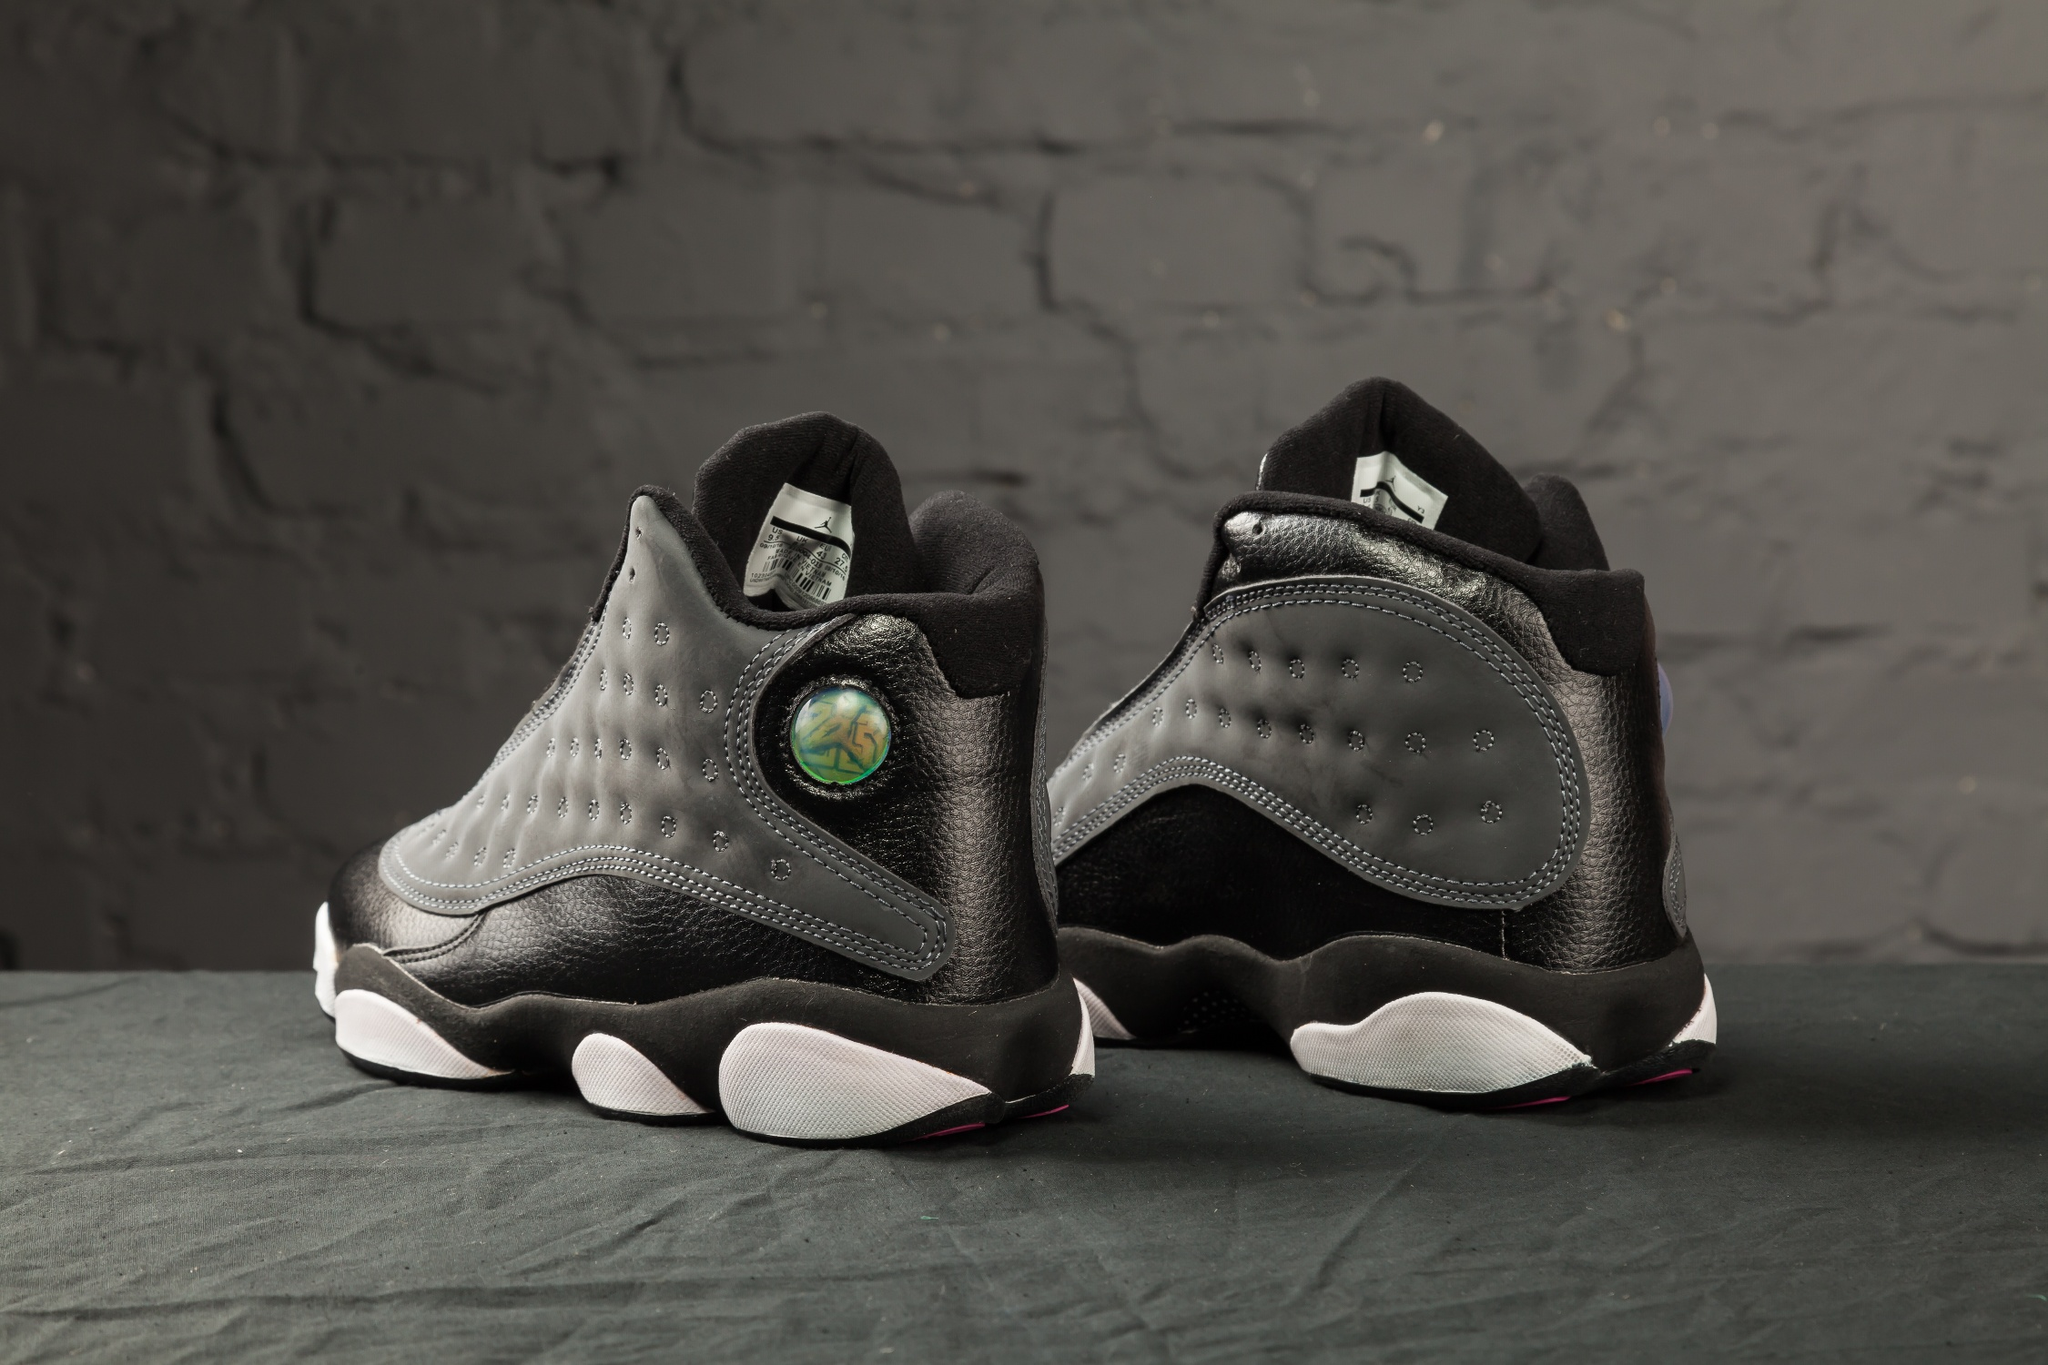What can you say about the details of the sneakers? The sneakers are intricately designed, featuring a combination of smooth black leather and textured gray patches. The black upper is studded with subtle perforations that add to the sleek aesthetic. The standout feature is a holographic circular emblem near the heel, which captures the light and adds a unique flair. The interior appears to be well-padded, suggesting comfort. The white soles bear a slightly textured grip, indicating practicality in addition to style. Overall, the sneakers are a blend of modern fashion and usability. Can you provide some imaginative context for these sneakers? These sneakers could easily belong to an urban explorer in a futuristic cityscape. Picture a world where style and adaptability are key, and our explorer navigates neon-lit streets and towering skyscrapers. The holographic logo on the sneakers might be a tech-enhanced feature, unlocking special functions or serving as an ID for accessing exclusive locations. The sturdy yet fashionable build ensures that the wearer is prepared for anything, blending seamlessly into both high-society events and gritty underground meetups. Describe a realistic scenario where someone might wear these sneakers. These sneakers could be worn by a young professional in a bustling city. They might pair them with slim-fit jeans and a stylish jacket, perfect for a day that transitions from office meetings to evening social gatherings. The shoes' design ensures they stand out in a corporate environment while providing the comfort needed for a walk home through the urban jungle. What kind of activities can be performed with these sneakers? Due to their trendy yet practical design, these sneakers are versatile for various activities. The sturdy sole and comfortable padding make them ideal for a day of city sightseeing, complete with walks through parks and visits to art galleries. They would also be suitable for attending a casual concert or a street festival, where both comfort and style are essential. Additionally, they could easily transition into a gym setting for a workout session, thanks to their robust build and supportive design. 